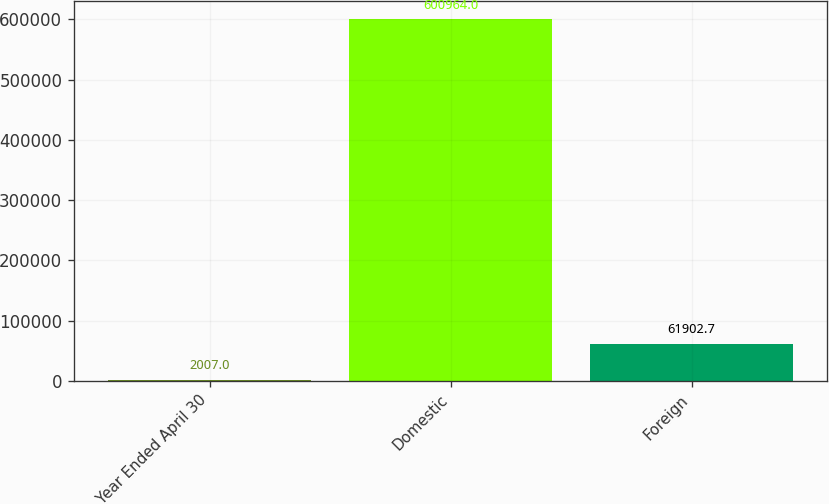Convert chart. <chart><loc_0><loc_0><loc_500><loc_500><bar_chart><fcel>Year Ended April 30<fcel>Domestic<fcel>Foreign<nl><fcel>2007<fcel>600964<fcel>61902.7<nl></chart> 